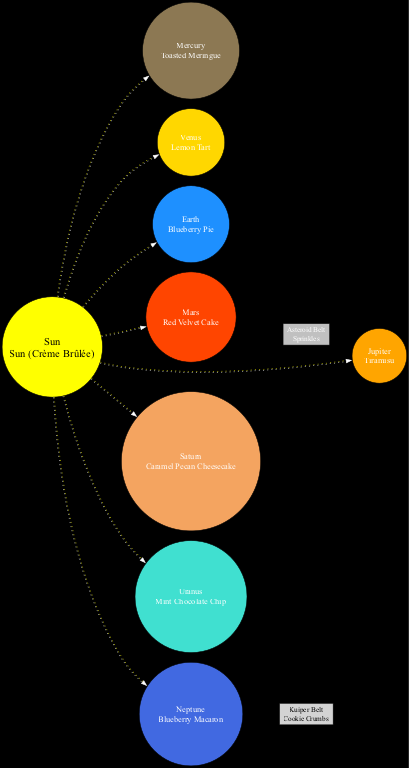What dessert flavor is associated with Earth? The diagram labels Earth with the flavor "Blueberry Pie." This can be determined by looking directly at the label associated with the Earth node.
Answer: Blueberry Pie How many planets are there in the solar system diagram? By counting the nodes labeled for planets, we can see there are eight labeled planets. Each planet from Mercury to Neptune is counted to determine this total.
Answer: 8 What is the flavor associated with Saturn? Saturn is labeled with the flavor "Caramel Pecan Cheesecake" in the diagram. By checking the label next to Saturn, this information is found.
Answer: Caramel Pecan Cheesecake Which planet is closest to the Sun? Mercury is the planet labeled closest to the Sun in the diagram, as it is positioned directly next to the Sun node with a line connecting them.
Answer: Mercury What is the label for the Kuiper Belt in the diagram? The Kuiper Belt is labeled "Cookie Crumbs" in the diagram. This can be verified by looking at the node specifically marked for the Kuiper Belt.
Answer: Cookie Crumbs Which dessert flavor is represented by Mars? The label for Mars indicates the flavor "Red Velvet Cake." This can be confirmed by checking the Mars node in the diagram.
Answer: Red Velvet Cake How many different dessert flavors are represented in this diagram? There are eight different dessert flavors labeled for each planet along with the Sun's flavor, totaling nine flavors altogether. We can count all unique flavors from the nodes.
Answer: 9 What connects Mars to the Asteroid Belt? In the diagram, a dotted line connects Mars to the Asteroid Belt, indicating their relationship. We interpret this connection by examining the edges and nodes that are labeled.
Answer: Dotted line Which dessert flavor is Jupiter associated with? Jupiter is associated with the flavor "Tiramisu" as indicated by the label next to the Jupiter node. This information is directly read from the diagram.
Answer: Tiramisu 